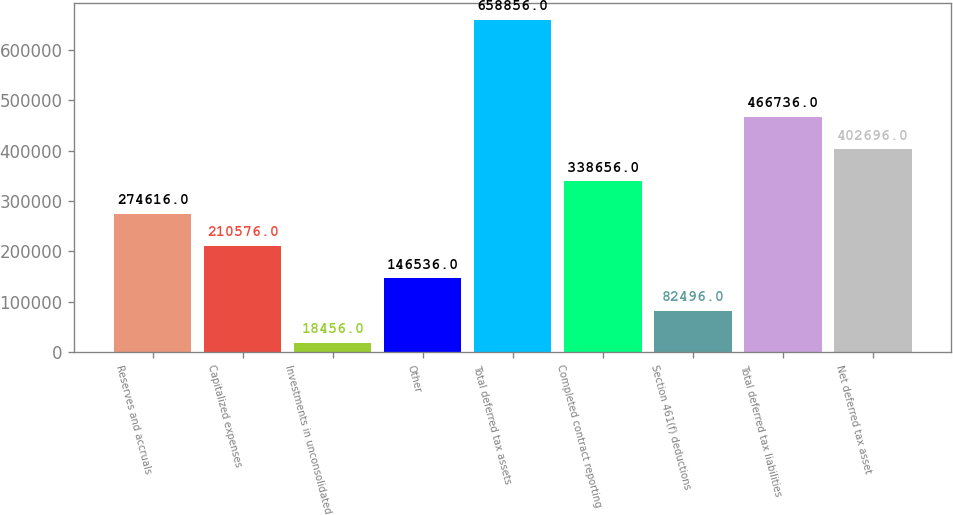Convert chart. <chart><loc_0><loc_0><loc_500><loc_500><bar_chart><fcel>Reserves and accruals<fcel>Capitalized expenses<fcel>Investments in unconsolidated<fcel>Other<fcel>Total deferred tax assets<fcel>Completed contract reporting<fcel>Section 461(f) deductions<fcel>Total deferred tax liabilities<fcel>Net deferred tax asset<nl><fcel>274616<fcel>210576<fcel>18456<fcel>146536<fcel>658856<fcel>338656<fcel>82496<fcel>466736<fcel>402696<nl></chart> 